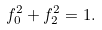Convert formula to latex. <formula><loc_0><loc_0><loc_500><loc_500>f _ { 0 } ^ { 2 } + f _ { 2 } ^ { 2 } = 1 .</formula> 